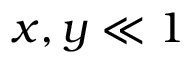Convert formula to latex. <formula><loc_0><loc_0><loc_500><loc_500>x , y \ll 1</formula> 